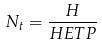Convert formula to latex. <formula><loc_0><loc_0><loc_500><loc_500>N _ { t } = \frac { H } { H E T P }</formula> 